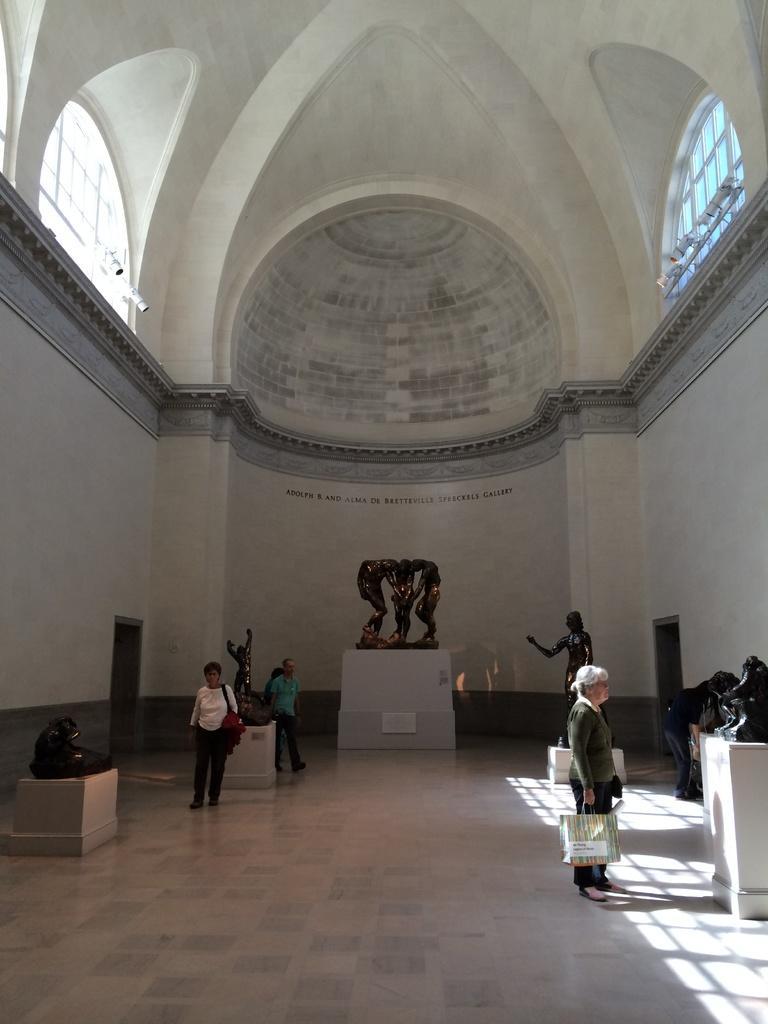Describe this image in one or two sentences. This image is taken in the hall. In this image there are sculptures and we can see people. In the background there is a wall and we can see text written on the wall. At the top there are windows. 